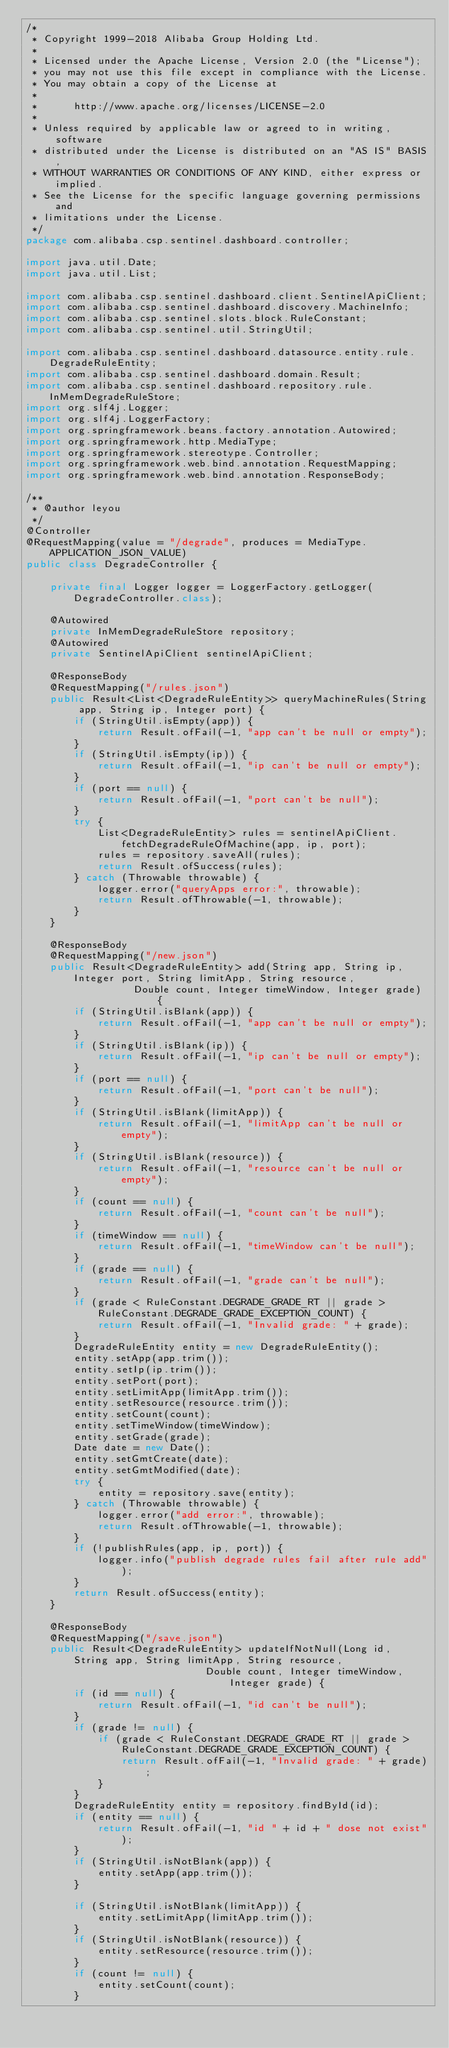<code> <loc_0><loc_0><loc_500><loc_500><_Java_>/*
 * Copyright 1999-2018 Alibaba Group Holding Ltd.
 *
 * Licensed under the Apache License, Version 2.0 (the "License");
 * you may not use this file except in compliance with the License.
 * You may obtain a copy of the License at
 *
 *      http://www.apache.org/licenses/LICENSE-2.0
 *
 * Unless required by applicable law or agreed to in writing, software
 * distributed under the License is distributed on an "AS IS" BASIS,
 * WITHOUT WARRANTIES OR CONDITIONS OF ANY KIND, either express or implied.
 * See the License for the specific language governing permissions and
 * limitations under the License.
 */
package com.alibaba.csp.sentinel.dashboard.controller;

import java.util.Date;
import java.util.List;

import com.alibaba.csp.sentinel.dashboard.client.SentinelApiClient;
import com.alibaba.csp.sentinel.dashboard.discovery.MachineInfo;
import com.alibaba.csp.sentinel.slots.block.RuleConstant;
import com.alibaba.csp.sentinel.util.StringUtil;

import com.alibaba.csp.sentinel.dashboard.datasource.entity.rule.DegradeRuleEntity;
import com.alibaba.csp.sentinel.dashboard.domain.Result;
import com.alibaba.csp.sentinel.dashboard.repository.rule.InMemDegradeRuleStore;
import org.slf4j.Logger;
import org.slf4j.LoggerFactory;
import org.springframework.beans.factory.annotation.Autowired;
import org.springframework.http.MediaType;
import org.springframework.stereotype.Controller;
import org.springframework.web.bind.annotation.RequestMapping;
import org.springframework.web.bind.annotation.ResponseBody;

/**
 * @author leyou
 */
@Controller
@RequestMapping(value = "/degrade", produces = MediaType.APPLICATION_JSON_VALUE)
public class DegradeController {

    private final Logger logger = LoggerFactory.getLogger(DegradeController.class);

    @Autowired
    private InMemDegradeRuleStore repository;
    @Autowired
    private SentinelApiClient sentinelApiClient;

    @ResponseBody
    @RequestMapping("/rules.json")
    public Result<List<DegradeRuleEntity>> queryMachineRules(String app, String ip, Integer port) {
        if (StringUtil.isEmpty(app)) {
            return Result.ofFail(-1, "app can't be null or empty");
        }
        if (StringUtil.isEmpty(ip)) {
            return Result.ofFail(-1, "ip can't be null or empty");
        }
        if (port == null) {
            return Result.ofFail(-1, "port can't be null");
        }
        try {
            List<DegradeRuleEntity> rules = sentinelApiClient.fetchDegradeRuleOfMachine(app, ip, port);
            rules = repository.saveAll(rules);
            return Result.ofSuccess(rules);
        } catch (Throwable throwable) {
            logger.error("queryApps error:", throwable);
            return Result.ofThrowable(-1, throwable);
        }
    }

    @ResponseBody
    @RequestMapping("/new.json")
    public Result<DegradeRuleEntity> add(String app, String ip, Integer port, String limitApp, String resource,
                  Double count, Integer timeWindow, Integer grade) {
        if (StringUtil.isBlank(app)) {
            return Result.ofFail(-1, "app can't be null or empty");
        }
        if (StringUtil.isBlank(ip)) {
            return Result.ofFail(-1, "ip can't be null or empty");
        }
        if (port == null) {
            return Result.ofFail(-1, "port can't be null");
        }
        if (StringUtil.isBlank(limitApp)) {
            return Result.ofFail(-1, "limitApp can't be null or empty");
        }
        if (StringUtil.isBlank(resource)) {
            return Result.ofFail(-1, "resource can't be null or empty");
        }
        if (count == null) {
            return Result.ofFail(-1, "count can't be null");
        }
        if (timeWindow == null) {
            return Result.ofFail(-1, "timeWindow can't be null");
        }
        if (grade == null) {
            return Result.ofFail(-1, "grade can't be null");
        }
        if (grade < RuleConstant.DEGRADE_GRADE_RT || grade > RuleConstant.DEGRADE_GRADE_EXCEPTION_COUNT) {
            return Result.ofFail(-1, "Invalid grade: " + grade);
        }
        DegradeRuleEntity entity = new DegradeRuleEntity();
        entity.setApp(app.trim());
        entity.setIp(ip.trim());
        entity.setPort(port);
        entity.setLimitApp(limitApp.trim());
        entity.setResource(resource.trim());
        entity.setCount(count);
        entity.setTimeWindow(timeWindow);
        entity.setGrade(grade);
        Date date = new Date();
        entity.setGmtCreate(date);
        entity.setGmtModified(date);
        try {
            entity = repository.save(entity);
        } catch (Throwable throwable) {
            logger.error("add error:", throwable);
            return Result.ofThrowable(-1, throwable);
        }
        if (!publishRules(app, ip, port)) {
            logger.info("publish degrade rules fail after rule add");
        }
        return Result.ofSuccess(entity);
    }

    @ResponseBody
    @RequestMapping("/save.json")
    public Result<DegradeRuleEntity> updateIfNotNull(Long id, String app, String limitApp, String resource,
                              Double count, Integer timeWindow, Integer grade) {
        if (id == null) {
            return Result.ofFail(-1, "id can't be null");
        }
        if (grade != null) {
            if (grade < RuleConstant.DEGRADE_GRADE_RT || grade > RuleConstant.DEGRADE_GRADE_EXCEPTION_COUNT) {
                return Result.ofFail(-1, "Invalid grade: " + grade);
            }
        }
        DegradeRuleEntity entity = repository.findById(id);
        if (entity == null) {
            return Result.ofFail(-1, "id " + id + " dose not exist");
        }
        if (StringUtil.isNotBlank(app)) {
            entity.setApp(app.trim());
        }

        if (StringUtil.isNotBlank(limitApp)) {
            entity.setLimitApp(limitApp.trim());
        }
        if (StringUtil.isNotBlank(resource)) {
            entity.setResource(resource.trim());
        }
        if (count != null) {
            entity.setCount(count);
        }</code> 